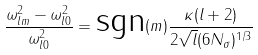<formula> <loc_0><loc_0><loc_500><loc_500>\frac { \omega _ { l m } ^ { 2 } - \omega ^ { 2 } _ { l 0 } } { \omega ^ { 2 } _ { l 0 } } = \text {sgn} ( m ) \frac { \kappa ( l + 2 ) } { 2 \sqrt { l } ( 6 N _ { \sigma } ) ^ { 1 / 3 } }</formula> 